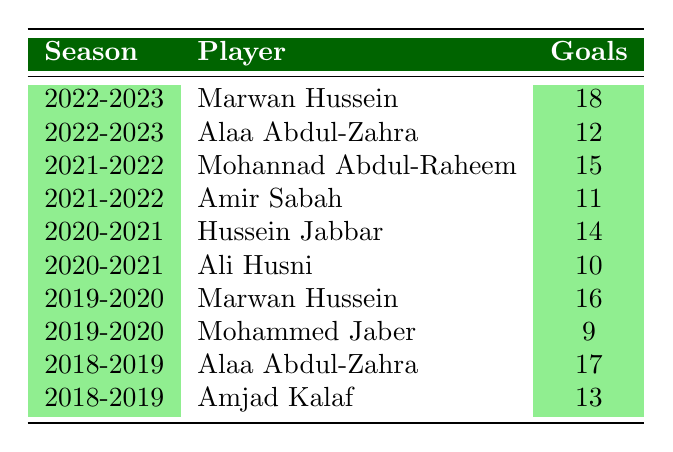What is the total number of goals scored by Marwan Hussein over the seasons listed? From the table, Marwan Hussein scored 18 goals in the 2022-2023 season and 16 goals in the 2019-2020 season. Adding these together gives us 18 + 16 = 34 goals.
Answer: 34 Which player scored the most goals in the 2021-2022 season? By examining the 2021-2022 row, Mohannad Abdul-Raheem scored 15 goals, while Amir Sabah scored 11 goals. Therefore, the player with the most goals that season is Mohannad Abdul-Raheem.
Answer: Mohannad Abdul-Raheem Did Alaa Abdul-Zahra score more goals in 2018-2019 than in 2022-2023? Alaa Abdul-Zahra scored 17 goals in the 2018-2019 season and 12 goals in the 2022-2023 season. Since 17 is greater than 12, the statement is true.
Answer: Yes What is the average number of goals scored by Ali Husni in the table? Ali Husni only appears once in the table and scored 10 goals in the 2020-2021 season. Thus, the average is simply 10, as there are no other data points for him.
Answer: 10 Which season had the lowest total goals scored by the top scorer of Al-Talaba? Looking at the table, the 2020-2021 season had Hussein Jabbar as the top scorer with 14 goals, which is less than all the other top scores in the table.
Answer: 2020-2021 How many goals did Alaa Abdul-Zahra score over the past five seasons? Alaa Abdul-Zahra scored 12 goals in 2022-2023 and 17 goals in 2018-2019. Summing these gives 12 + 17 = 29 goals over the five seasons.
Answer: 29 Was the top scorer for any season a player who also appeared in the previous season? Marwan Hussein scored in both 2019-2020 (16 goals) and 2022-2023 (18 goals), indicating he was the top scorer in non-consecutive seasons. This confirms that indeed a player scored in both seasons.
Answer: Yes Which player scored the fewest goals in a single season according to the table? Analyzing all the rows, Mohammed Jaber scored 9 goals in the 2019-2020 season, which is fewer than any other player in other seasons.
Answer: Mohammed Jaber In how many seasons did the top goal scorer score more than 15 goals? The seasons with scorers more than 15 goals are: 2022-2023 (Marwan Hussein: 18), 2021-2022 (Mohannad Abdul-Raheem: 15), 2019-2020 (Marwan Hussein: 16), and 2018-2019 (Alaa Abdul-Zahra: 17). Therefore, there are four such seasons.
Answer: 4 